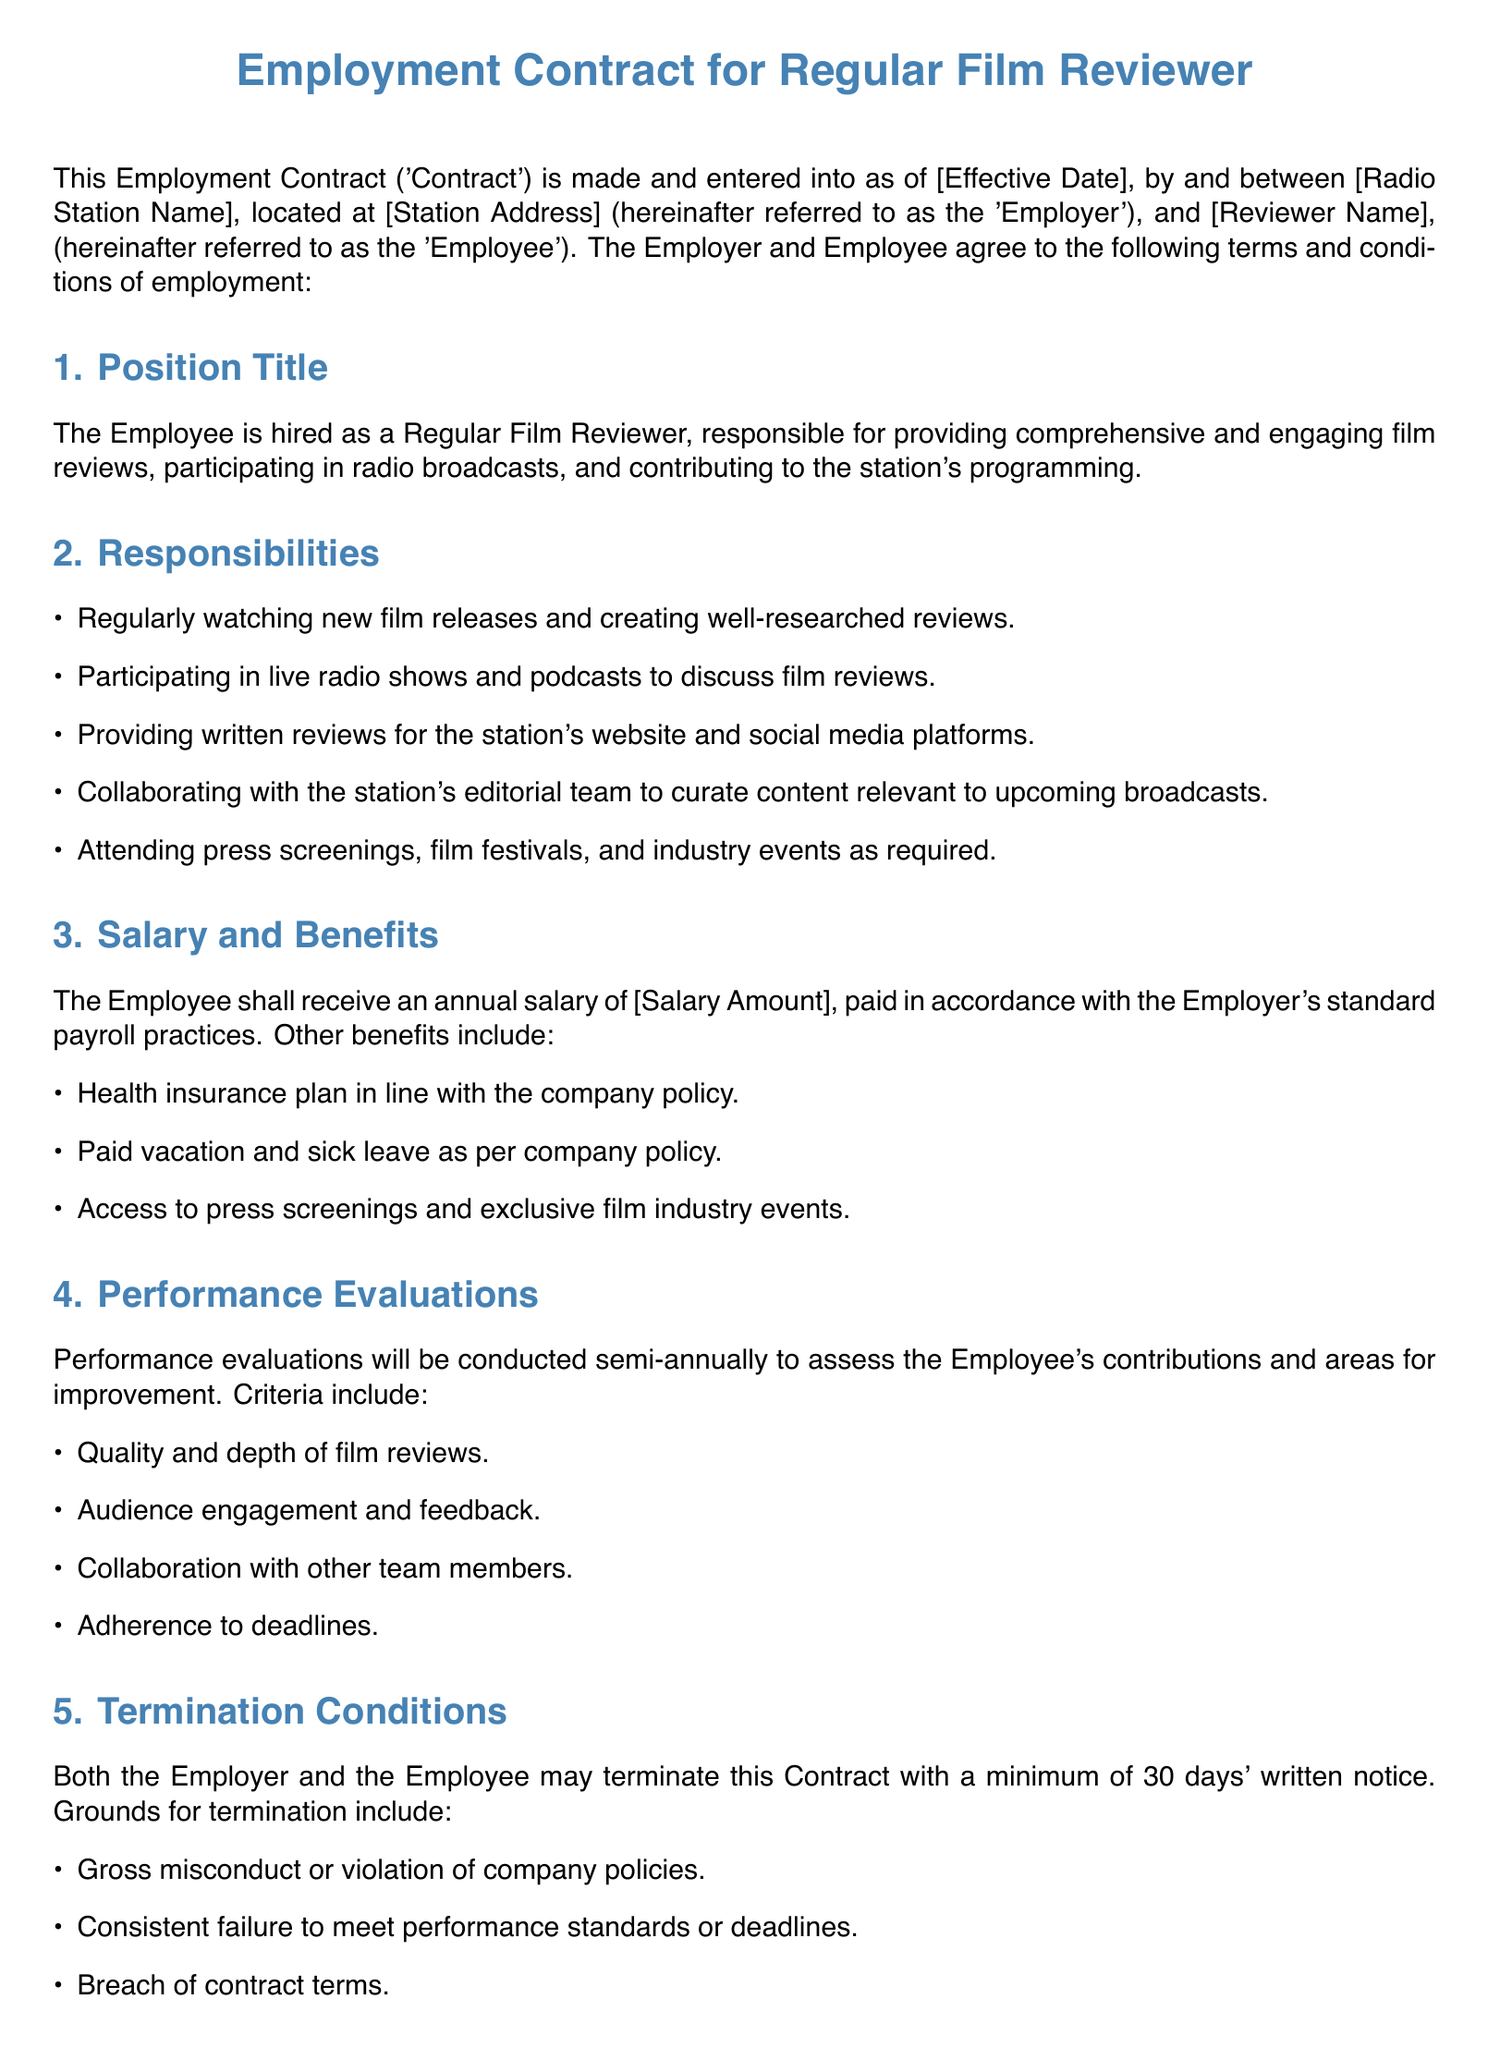What is the position title? The position title is specified in the document under section 1, which describes the Employee's role as a Regular Film Reviewer.
Answer: Regular Film Reviewer What is the annual salary? The annual salary is mentioned in section 3, detailing the compensation for the Employee's role.
Answer: [Salary Amount] How often will performance evaluations be conducted? Section 4 states the frequency of performance evaluations, which is semi-annually, to assess the Employee's contributions.
Answer: Semi-annually What are the grounds for termination? Section 5 lists the conditions under which either party may terminate the contract, focusing on misconduct and performance issues.
Answer: Gross misconduct, consistent failure to meet performance standards, breach of contract terms What benefits are included in the contract? Section 3 outlines benefits provided to the Employee, which includes various offerings related to health and work-life balance.
Answer: Health insurance, paid vacation, sick leave, and access to events How much notice is required for termination? Section 5 specifies the notice period required for termination, which both parties must adhere to.
Answer: 30 days 